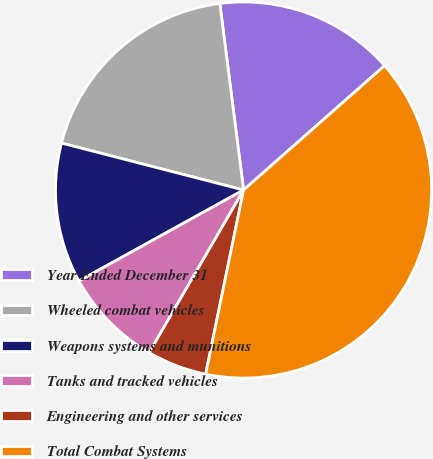Convert chart. <chart><loc_0><loc_0><loc_500><loc_500><pie_chart><fcel>Year Ended December 31<fcel>Wheeled combat vehicles<fcel>Weapons systems and munitions<fcel>Tanks and tracked vehicles<fcel>Engineering and other services<fcel>Total Combat Systems<nl><fcel>15.51%<fcel>18.97%<fcel>12.05%<fcel>8.59%<fcel>5.14%<fcel>39.73%<nl></chart> 